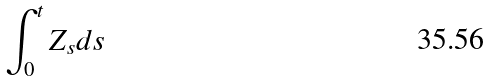<formula> <loc_0><loc_0><loc_500><loc_500>\int _ { 0 } ^ { t } Z _ { s } d s</formula> 